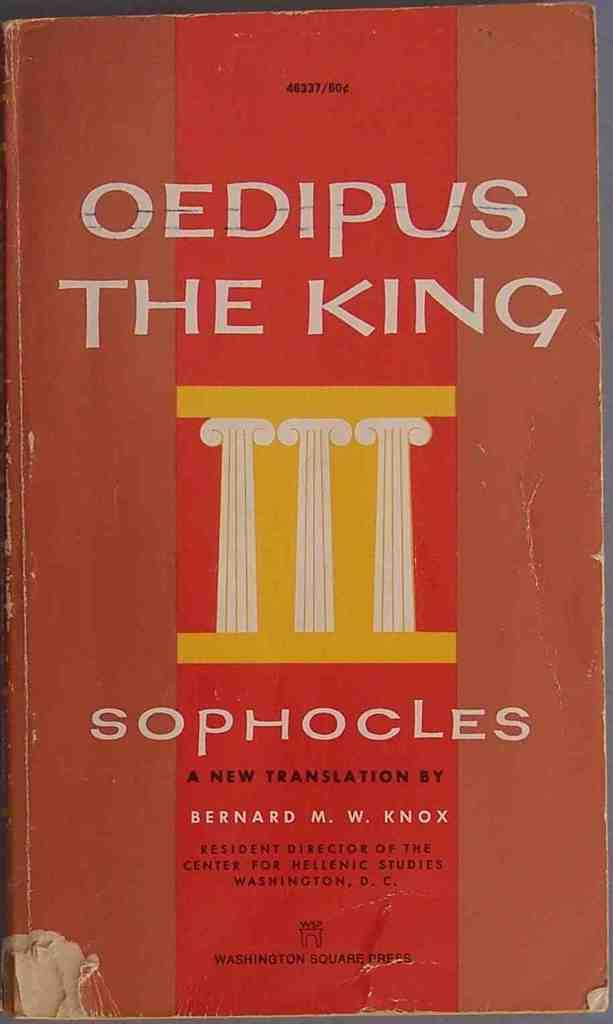<image>
Write a terse but informative summary of the picture. The cover of the book "Oedipus The King" translated by Bernard M. W. Knox. 